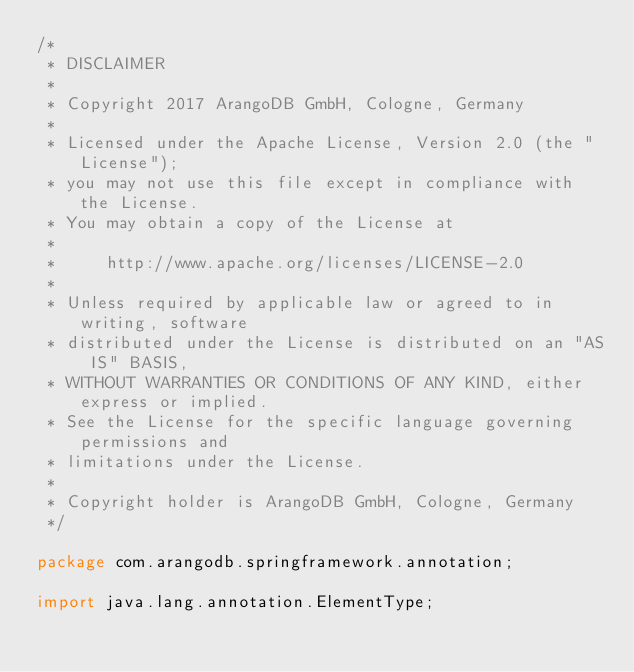<code> <loc_0><loc_0><loc_500><loc_500><_Java_>/*
 * DISCLAIMER
 *
 * Copyright 2017 ArangoDB GmbH, Cologne, Germany
 *
 * Licensed under the Apache License, Version 2.0 (the "License");
 * you may not use this file except in compliance with the License.
 * You may obtain a copy of the License at
 *
 *     http://www.apache.org/licenses/LICENSE-2.0
 *
 * Unless required by applicable law or agreed to in writing, software
 * distributed under the License is distributed on an "AS IS" BASIS,
 * WITHOUT WARRANTIES OR CONDITIONS OF ANY KIND, either express or implied.
 * See the License for the specific language governing permissions and
 * limitations under the License.
 *
 * Copyright holder is ArangoDB GmbH, Cologne, Germany
 */

package com.arangodb.springframework.annotation;

import java.lang.annotation.ElementType;</code> 